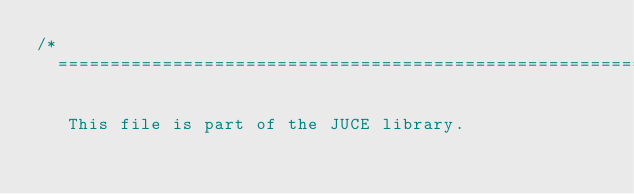Convert code to text. <code><loc_0><loc_0><loc_500><loc_500><_ObjectiveC_>/*
  ==============================================================================

   This file is part of the JUCE library.</code> 